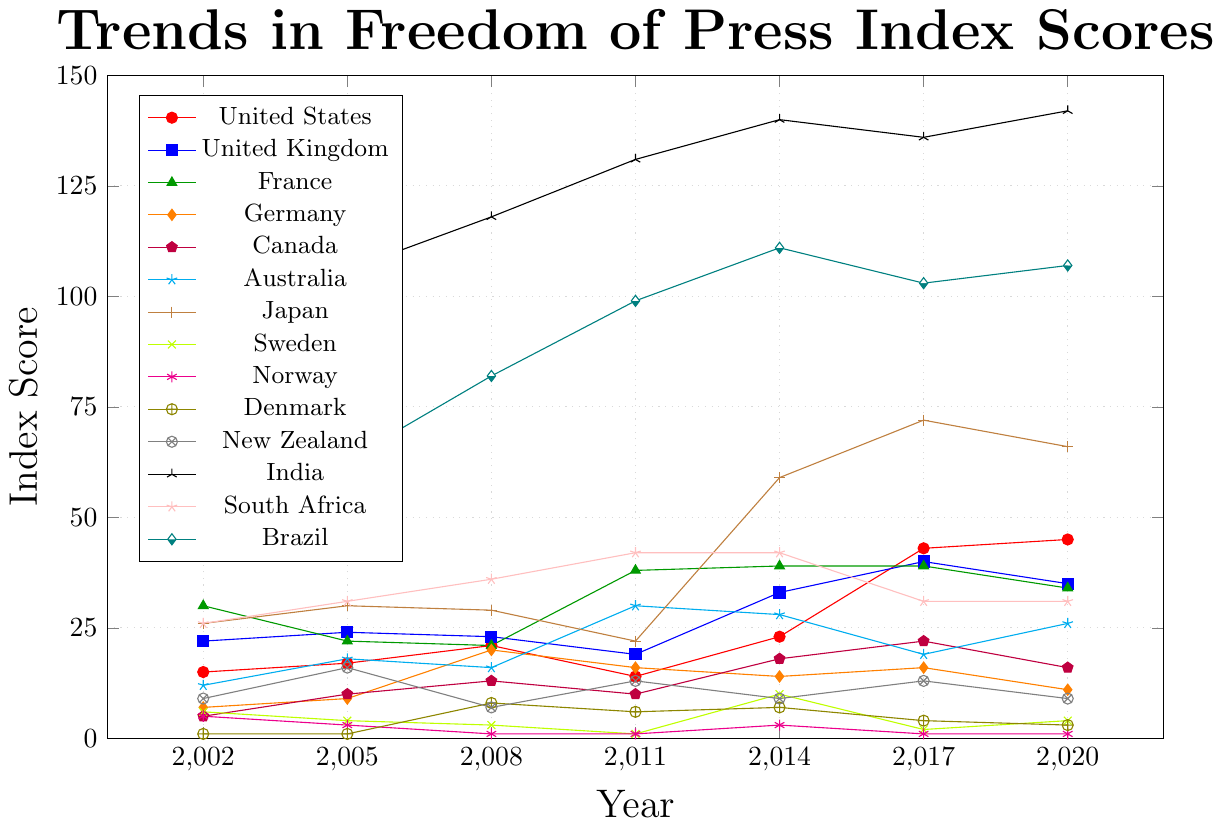Which country experienced the largest increase in its freedom of the press index score between 2002 and 2020? To determine the largest increase, subtract the 2002 score from the 2020 score for each country. Compare these results: United States (45-15=30), United Kingdom (35-22=13), France (34-30=4), Germany (11-7=4), Canada (16-5=11), Australia (26-12=14), Japan (66-26=40), Sweden (4-6=-2), Norway (1-5=-4), Denmark (3-1=2), New Zealand (9-9=0), India (142-80=62), South Africa (31-26=5), Brazil (107-54=53). The largest increase is India with an increase of 62 points.
Answer: India Which country had the best index score in 2020? Look for the country with the lowest index score in 2020. From the chart: Norway (1), Sweden (4), Denmark (3), etc. The lowest score is for Norway.
Answer: Norway What is the average freedom of press index score for Germany across all years shown? Add Germany's scores for the years and divide by the number of years. (7+9+20+16+14+16+11)/7. This totals to 93. Dividing by 7, the average is 93/7 = ~13.29.
Answer: ~13.29 Which countries' freedom of press index scores worsened between 2011 and 2017? Compare scores between 2011 and 2017 for all countries: United States (14-43), United Kingdom (19-40), France (38-39), Germany (16-16), Canada (10-22), Australia (30-19), Japan (22-72), Sweden (1-2), Norway (1-1), Denmark (6-4), New Zealand (13-13), India (131-136), South Africa (42-31), Brazil (99-103). Countries with a worsened score: United States, United Kingdom, France, Canada, Japan, India, Brazil.
Answer: United States, United Kingdom, France, Canada, Japan, India, Brazil Between 2002 and 2020, which countries saw their freedom of press index scores improve? To determine improvement, compare the 2002 and 2020 scores for each country where the latter should be lower than the former: Germany (7-11=-4), Norway (5-1=-4). Only Germany and Norway show improvement.
Answer: Germany, Norway 